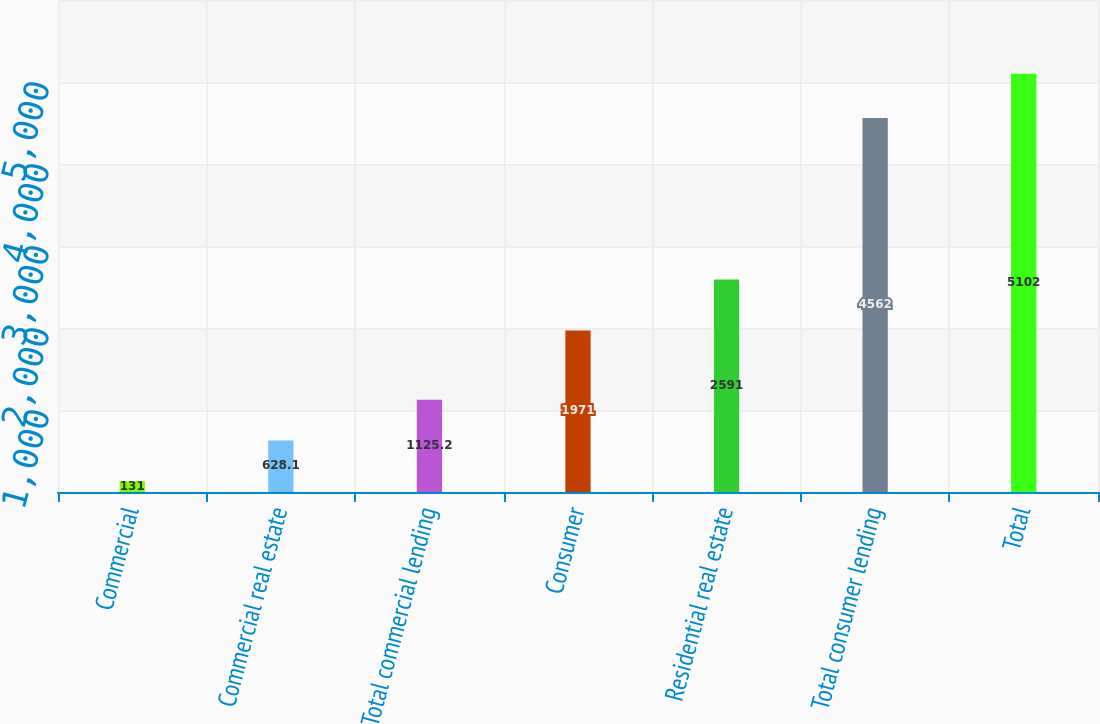<chart> <loc_0><loc_0><loc_500><loc_500><bar_chart><fcel>Commercial<fcel>Commercial real estate<fcel>Total commercial lending<fcel>Consumer<fcel>Residential real estate<fcel>Total consumer lending<fcel>Total<nl><fcel>131<fcel>628.1<fcel>1125.2<fcel>1971<fcel>2591<fcel>4562<fcel>5102<nl></chart> 